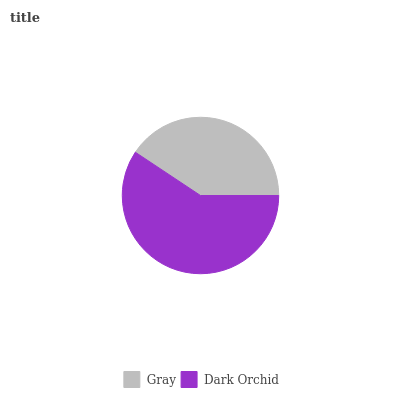Is Gray the minimum?
Answer yes or no. Yes. Is Dark Orchid the maximum?
Answer yes or no. Yes. Is Dark Orchid the minimum?
Answer yes or no. No. Is Dark Orchid greater than Gray?
Answer yes or no. Yes. Is Gray less than Dark Orchid?
Answer yes or no. Yes. Is Gray greater than Dark Orchid?
Answer yes or no. No. Is Dark Orchid less than Gray?
Answer yes or no. No. Is Dark Orchid the high median?
Answer yes or no. Yes. Is Gray the low median?
Answer yes or no. Yes. Is Gray the high median?
Answer yes or no. No. Is Dark Orchid the low median?
Answer yes or no. No. 